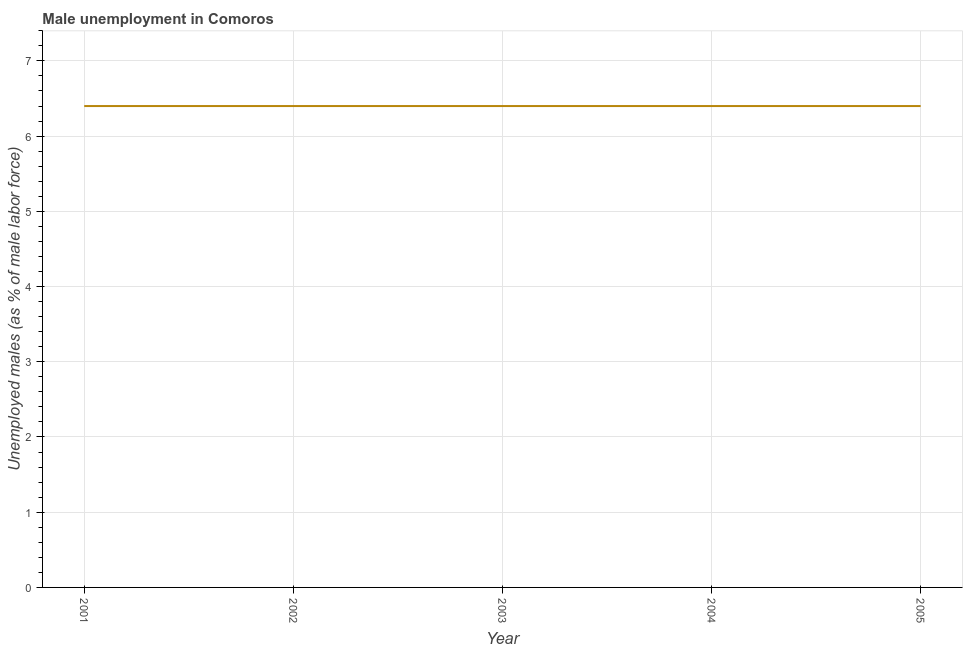What is the unemployed males population in 2002?
Your response must be concise. 6.4. Across all years, what is the maximum unemployed males population?
Offer a terse response. 6.4. Across all years, what is the minimum unemployed males population?
Your response must be concise. 6.4. In which year was the unemployed males population maximum?
Provide a short and direct response. 2001. In which year was the unemployed males population minimum?
Your answer should be compact. 2001. What is the sum of the unemployed males population?
Your response must be concise. 32. What is the average unemployed males population per year?
Your answer should be compact. 6.4. What is the median unemployed males population?
Give a very brief answer. 6.4. In how many years, is the unemployed males population greater than 2.4 %?
Provide a short and direct response. 5. Is the difference between the unemployed males population in 2001 and 2005 greater than the difference between any two years?
Make the answer very short. Yes. What is the difference between the highest and the second highest unemployed males population?
Your answer should be very brief. 0. Is the sum of the unemployed males population in 2001 and 2003 greater than the maximum unemployed males population across all years?
Keep it short and to the point. Yes. What is the difference between the highest and the lowest unemployed males population?
Keep it short and to the point. 0. How many lines are there?
Provide a short and direct response. 1. How many years are there in the graph?
Your answer should be compact. 5. Are the values on the major ticks of Y-axis written in scientific E-notation?
Your response must be concise. No. Does the graph contain grids?
Ensure brevity in your answer.  Yes. What is the title of the graph?
Offer a very short reply. Male unemployment in Comoros. What is the label or title of the X-axis?
Your response must be concise. Year. What is the label or title of the Y-axis?
Keep it short and to the point. Unemployed males (as % of male labor force). What is the Unemployed males (as % of male labor force) in 2001?
Offer a very short reply. 6.4. What is the Unemployed males (as % of male labor force) in 2002?
Your response must be concise. 6.4. What is the Unemployed males (as % of male labor force) in 2003?
Make the answer very short. 6.4. What is the Unemployed males (as % of male labor force) of 2004?
Your response must be concise. 6.4. What is the Unemployed males (as % of male labor force) of 2005?
Make the answer very short. 6.4. What is the difference between the Unemployed males (as % of male labor force) in 2001 and 2002?
Provide a short and direct response. 0. What is the difference between the Unemployed males (as % of male labor force) in 2001 and 2004?
Offer a terse response. 0. What is the difference between the Unemployed males (as % of male labor force) in 2001 and 2005?
Provide a succinct answer. 0. What is the difference between the Unemployed males (as % of male labor force) in 2002 and 2004?
Offer a terse response. 0. What is the difference between the Unemployed males (as % of male labor force) in 2004 and 2005?
Keep it short and to the point. 0. What is the ratio of the Unemployed males (as % of male labor force) in 2001 to that in 2003?
Offer a terse response. 1. What is the ratio of the Unemployed males (as % of male labor force) in 2001 to that in 2004?
Give a very brief answer. 1. What is the ratio of the Unemployed males (as % of male labor force) in 2001 to that in 2005?
Your response must be concise. 1. What is the ratio of the Unemployed males (as % of male labor force) in 2003 to that in 2005?
Your response must be concise. 1. 